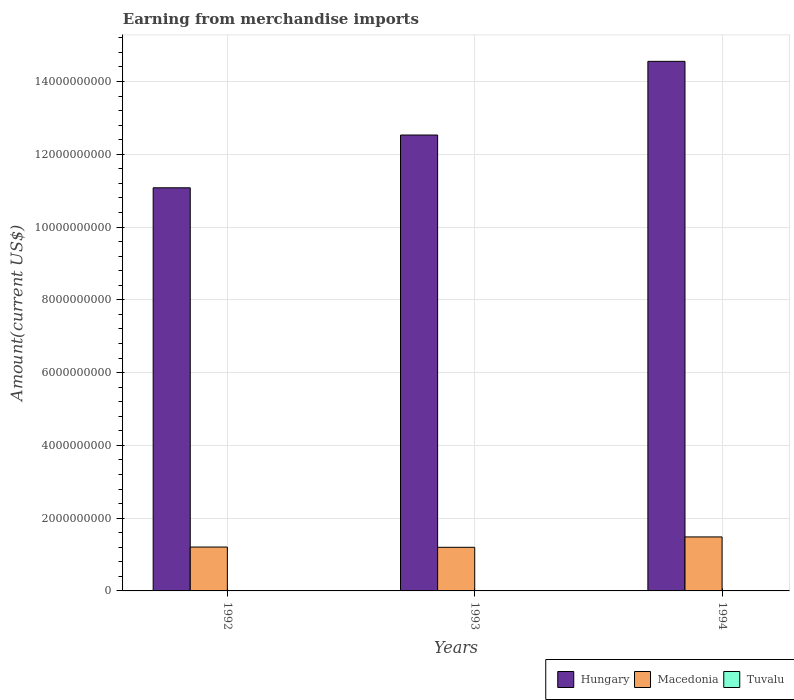How many different coloured bars are there?
Offer a terse response. 3. How many groups of bars are there?
Your answer should be compact. 3. Are the number of bars per tick equal to the number of legend labels?
Provide a succinct answer. Yes. Are the number of bars on each tick of the X-axis equal?
Keep it short and to the point. Yes. How many bars are there on the 1st tick from the left?
Your response must be concise. 3. How many bars are there on the 1st tick from the right?
Your answer should be very brief. 3. What is the amount earned from merchandise imports in Macedonia in 1993?
Ensure brevity in your answer.  1.20e+09. Across all years, what is the maximum amount earned from merchandise imports in Macedonia?
Your answer should be very brief. 1.48e+09. Across all years, what is the minimum amount earned from merchandise imports in Tuvalu?
Your response must be concise. 5.00e+06. In which year was the amount earned from merchandise imports in Tuvalu minimum?
Offer a very short reply. 1992. What is the total amount earned from merchandise imports in Tuvalu in the graph?
Provide a short and direct response. 1.96e+07. What is the difference between the amount earned from merchandise imports in Tuvalu in 1992 and that in 1993?
Offer a very short reply. -1.64e+06. What is the difference between the amount earned from merchandise imports in Tuvalu in 1993 and the amount earned from merchandise imports in Macedonia in 1994?
Provide a short and direct response. -1.48e+09. What is the average amount earned from merchandise imports in Macedonia per year?
Your answer should be very brief. 1.30e+09. In the year 1993, what is the difference between the amount earned from merchandise imports in Macedonia and amount earned from merchandise imports in Hungary?
Provide a succinct answer. -1.13e+1. In how many years, is the amount earned from merchandise imports in Macedonia greater than 14400000000 US$?
Provide a short and direct response. 0. What is the ratio of the amount earned from merchandise imports in Tuvalu in 1992 to that in 1993?
Provide a short and direct response. 0.75. Is the amount earned from merchandise imports in Macedonia in 1992 less than that in 1993?
Offer a very short reply. No. What is the difference between the highest and the second highest amount earned from merchandise imports in Tuvalu?
Keep it short and to the point. 1.34e+06. What is the difference between the highest and the lowest amount earned from merchandise imports in Hungary?
Your answer should be compact. 3.48e+09. In how many years, is the amount earned from merchandise imports in Hungary greater than the average amount earned from merchandise imports in Hungary taken over all years?
Keep it short and to the point. 1. What does the 1st bar from the left in 1993 represents?
Provide a short and direct response. Hungary. What does the 1st bar from the right in 1993 represents?
Ensure brevity in your answer.  Tuvalu. Are all the bars in the graph horizontal?
Keep it short and to the point. No. How many years are there in the graph?
Provide a short and direct response. 3. Does the graph contain any zero values?
Ensure brevity in your answer.  No. Where does the legend appear in the graph?
Ensure brevity in your answer.  Bottom right. How are the legend labels stacked?
Provide a short and direct response. Horizontal. What is the title of the graph?
Your response must be concise. Earning from merchandise imports. Does "Latin America(developing only)" appear as one of the legend labels in the graph?
Provide a short and direct response. No. What is the label or title of the Y-axis?
Ensure brevity in your answer.  Amount(current US$). What is the Amount(current US$) of Hungary in 1992?
Keep it short and to the point. 1.11e+1. What is the Amount(current US$) of Macedonia in 1992?
Your answer should be compact. 1.21e+09. What is the Amount(current US$) of Hungary in 1993?
Offer a very short reply. 1.25e+1. What is the Amount(current US$) of Macedonia in 1993?
Offer a very short reply. 1.20e+09. What is the Amount(current US$) of Tuvalu in 1993?
Make the answer very short. 6.64e+06. What is the Amount(current US$) of Hungary in 1994?
Ensure brevity in your answer.  1.46e+1. What is the Amount(current US$) in Macedonia in 1994?
Make the answer very short. 1.48e+09. What is the Amount(current US$) of Tuvalu in 1994?
Provide a short and direct response. 7.98e+06. Across all years, what is the maximum Amount(current US$) in Hungary?
Ensure brevity in your answer.  1.46e+1. Across all years, what is the maximum Amount(current US$) of Macedonia?
Keep it short and to the point. 1.48e+09. Across all years, what is the maximum Amount(current US$) of Tuvalu?
Your answer should be very brief. 7.98e+06. Across all years, what is the minimum Amount(current US$) of Hungary?
Keep it short and to the point. 1.11e+1. Across all years, what is the minimum Amount(current US$) of Macedonia?
Provide a succinct answer. 1.20e+09. What is the total Amount(current US$) of Hungary in the graph?
Your answer should be compact. 3.82e+1. What is the total Amount(current US$) of Macedonia in the graph?
Offer a terse response. 3.89e+09. What is the total Amount(current US$) of Tuvalu in the graph?
Give a very brief answer. 1.96e+07. What is the difference between the Amount(current US$) in Hungary in 1992 and that in 1993?
Give a very brief answer. -1.45e+09. What is the difference between the Amount(current US$) of Macedonia in 1992 and that in 1993?
Make the answer very short. 7.00e+06. What is the difference between the Amount(current US$) of Tuvalu in 1992 and that in 1993?
Your answer should be compact. -1.64e+06. What is the difference between the Amount(current US$) in Hungary in 1992 and that in 1994?
Your answer should be very brief. -3.48e+09. What is the difference between the Amount(current US$) in Macedonia in 1992 and that in 1994?
Your response must be concise. -2.78e+08. What is the difference between the Amount(current US$) in Tuvalu in 1992 and that in 1994?
Offer a terse response. -2.98e+06. What is the difference between the Amount(current US$) of Hungary in 1993 and that in 1994?
Give a very brief answer. -2.02e+09. What is the difference between the Amount(current US$) of Macedonia in 1993 and that in 1994?
Your response must be concise. -2.85e+08. What is the difference between the Amount(current US$) of Tuvalu in 1993 and that in 1994?
Keep it short and to the point. -1.34e+06. What is the difference between the Amount(current US$) in Hungary in 1992 and the Amount(current US$) in Macedonia in 1993?
Keep it short and to the point. 9.88e+09. What is the difference between the Amount(current US$) of Hungary in 1992 and the Amount(current US$) of Tuvalu in 1993?
Offer a very short reply. 1.11e+1. What is the difference between the Amount(current US$) in Macedonia in 1992 and the Amount(current US$) in Tuvalu in 1993?
Your answer should be very brief. 1.20e+09. What is the difference between the Amount(current US$) of Hungary in 1992 and the Amount(current US$) of Macedonia in 1994?
Provide a succinct answer. 9.60e+09. What is the difference between the Amount(current US$) in Hungary in 1992 and the Amount(current US$) in Tuvalu in 1994?
Your response must be concise. 1.11e+1. What is the difference between the Amount(current US$) of Macedonia in 1992 and the Amount(current US$) of Tuvalu in 1994?
Your answer should be very brief. 1.20e+09. What is the difference between the Amount(current US$) in Hungary in 1993 and the Amount(current US$) in Macedonia in 1994?
Your answer should be very brief. 1.10e+1. What is the difference between the Amount(current US$) in Hungary in 1993 and the Amount(current US$) in Tuvalu in 1994?
Your response must be concise. 1.25e+1. What is the difference between the Amount(current US$) of Macedonia in 1993 and the Amount(current US$) of Tuvalu in 1994?
Provide a succinct answer. 1.19e+09. What is the average Amount(current US$) of Hungary per year?
Offer a terse response. 1.27e+1. What is the average Amount(current US$) in Macedonia per year?
Provide a succinct answer. 1.30e+09. What is the average Amount(current US$) in Tuvalu per year?
Keep it short and to the point. 6.54e+06. In the year 1992, what is the difference between the Amount(current US$) of Hungary and Amount(current US$) of Macedonia?
Offer a terse response. 9.87e+09. In the year 1992, what is the difference between the Amount(current US$) of Hungary and Amount(current US$) of Tuvalu?
Give a very brief answer. 1.11e+1. In the year 1992, what is the difference between the Amount(current US$) of Macedonia and Amount(current US$) of Tuvalu?
Your answer should be compact. 1.20e+09. In the year 1993, what is the difference between the Amount(current US$) in Hungary and Amount(current US$) in Macedonia?
Your answer should be compact. 1.13e+1. In the year 1993, what is the difference between the Amount(current US$) of Hungary and Amount(current US$) of Tuvalu?
Give a very brief answer. 1.25e+1. In the year 1993, what is the difference between the Amount(current US$) in Macedonia and Amount(current US$) in Tuvalu?
Provide a short and direct response. 1.19e+09. In the year 1994, what is the difference between the Amount(current US$) in Hungary and Amount(current US$) in Macedonia?
Your answer should be very brief. 1.31e+1. In the year 1994, what is the difference between the Amount(current US$) in Hungary and Amount(current US$) in Tuvalu?
Offer a terse response. 1.45e+1. In the year 1994, what is the difference between the Amount(current US$) in Macedonia and Amount(current US$) in Tuvalu?
Keep it short and to the point. 1.48e+09. What is the ratio of the Amount(current US$) of Hungary in 1992 to that in 1993?
Offer a terse response. 0.88. What is the ratio of the Amount(current US$) of Tuvalu in 1992 to that in 1993?
Your response must be concise. 0.75. What is the ratio of the Amount(current US$) of Hungary in 1992 to that in 1994?
Provide a succinct answer. 0.76. What is the ratio of the Amount(current US$) of Macedonia in 1992 to that in 1994?
Your answer should be very brief. 0.81. What is the ratio of the Amount(current US$) of Tuvalu in 1992 to that in 1994?
Your answer should be compact. 0.63. What is the ratio of the Amount(current US$) of Hungary in 1993 to that in 1994?
Provide a succinct answer. 0.86. What is the ratio of the Amount(current US$) in Macedonia in 1993 to that in 1994?
Keep it short and to the point. 0.81. What is the ratio of the Amount(current US$) of Tuvalu in 1993 to that in 1994?
Ensure brevity in your answer.  0.83. What is the difference between the highest and the second highest Amount(current US$) in Hungary?
Offer a terse response. 2.02e+09. What is the difference between the highest and the second highest Amount(current US$) of Macedonia?
Provide a short and direct response. 2.78e+08. What is the difference between the highest and the second highest Amount(current US$) of Tuvalu?
Provide a short and direct response. 1.34e+06. What is the difference between the highest and the lowest Amount(current US$) in Hungary?
Keep it short and to the point. 3.48e+09. What is the difference between the highest and the lowest Amount(current US$) of Macedonia?
Provide a succinct answer. 2.85e+08. What is the difference between the highest and the lowest Amount(current US$) in Tuvalu?
Your response must be concise. 2.98e+06. 